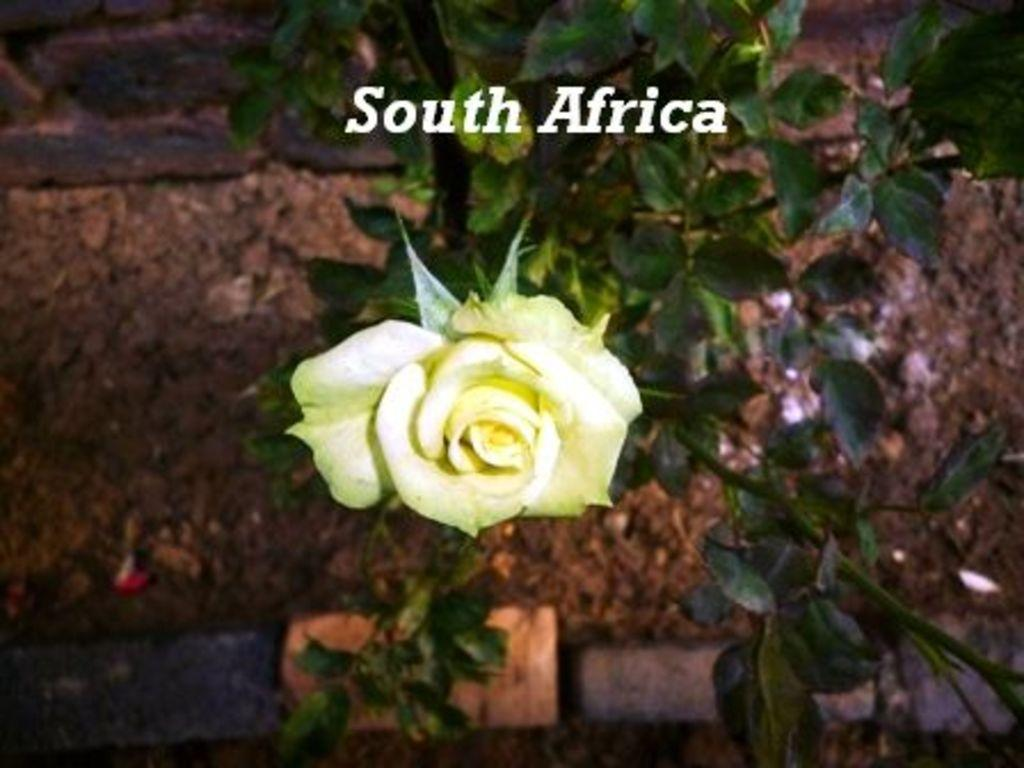What type of flower is in the image? There is a rose flower in the image. Where is the rose flower located? The rose flower is on a plant. What else can be seen at the top of the image? There is text written at the top of the image. What type of property is visible in the image? There is no property visible in the image; it features a rose flower on a plant and text at the top. Can you tell me how the carriage is being used in the image? There is no carriage present in the image. 